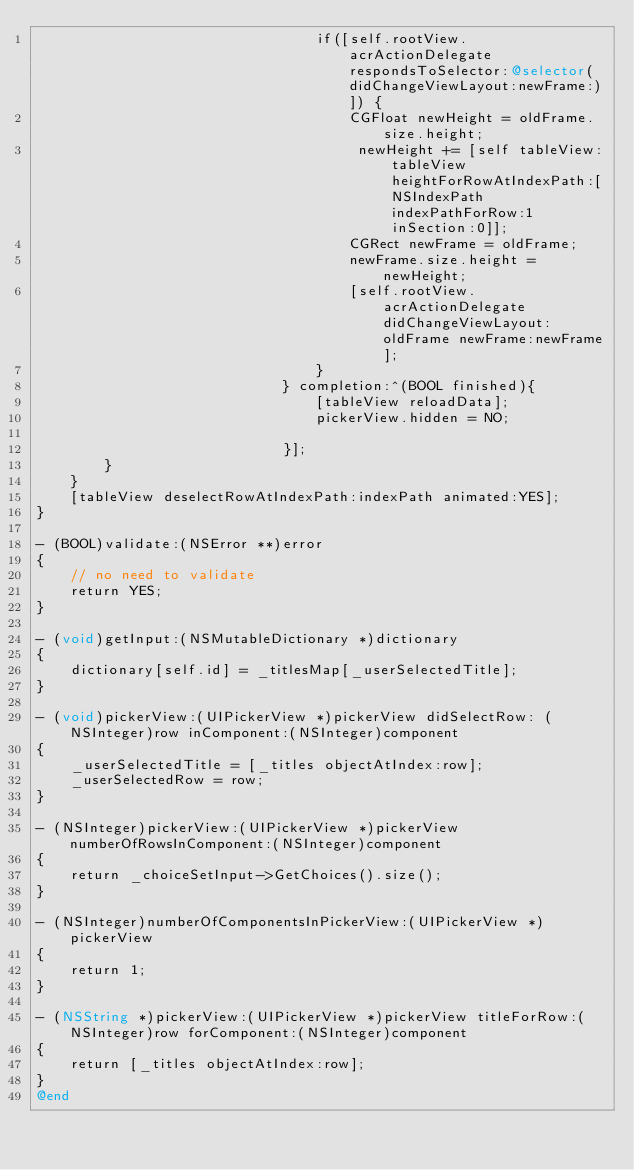<code> <loc_0><loc_0><loc_500><loc_500><_ObjectiveC_>                                 if([self.rootView.acrActionDelegate respondsToSelector:@selector(didChangeViewLayout:newFrame:)]) {
                                     CGFloat newHeight = oldFrame.size.height;
                                      newHeight += [self tableView:tableView heightForRowAtIndexPath:[NSIndexPath indexPathForRow:1 inSection:0]];
                                     CGRect newFrame = oldFrame;
                                     newFrame.size.height = newHeight;
                                     [self.rootView.acrActionDelegate didChangeViewLayout:oldFrame newFrame:newFrame];
                                 }
                             } completion:^(BOOL finished){
                                 [tableView reloadData];
                                 pickerView.hidden = NO;

                             }];
        }
    }
    [tableView deselectRowAtIndexPath:indexPath animated:YES];
}

- (BOOL)validate:(NSError **)error
{
    // no need to validate
    return YES;
}

- (void)getInput:(NSMutableDictionary *)dictionary
{
    dictionary[self.id] = _titlesMap[_userSelectedTitle];
}

- (void)pickerView:(UIPickerView *)pickerView didSelectRow: (NSInteger)row inComponent:(NSInteger)component
{
    _userSelectedTitle = [_titles objectAtIndex:row];
    _userSelectedRow = row;
}

- (NSInteger)pickerView:(UIPickerView *)pickerView numberOfRowsInComponent:(NSInteger)component
{
    return _choiceSetInput->GetChoices().size();
}

- (NSInteger)numberOfComponentsInPickerView:(UIPickerView *)pickerView
{
    return 1;
}

- (NSString *)pickerView:(UIPickerView *)pickerView titleForRow:(NSInteger)row forComponent:(NSInteger)component
{
    return [_titles objectAtIndex:row];
}
@end
</code> 